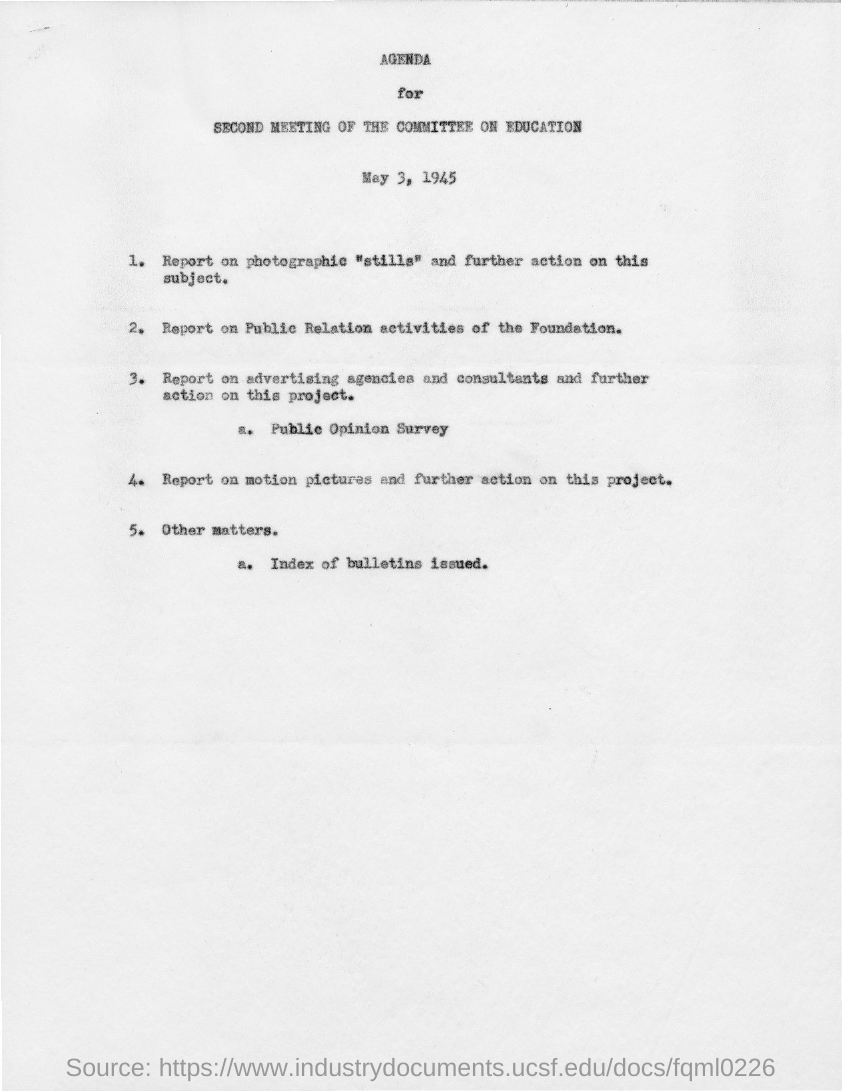When is the second meeting of the committee on education held?
Make the answer very short. May 3, 1945. 